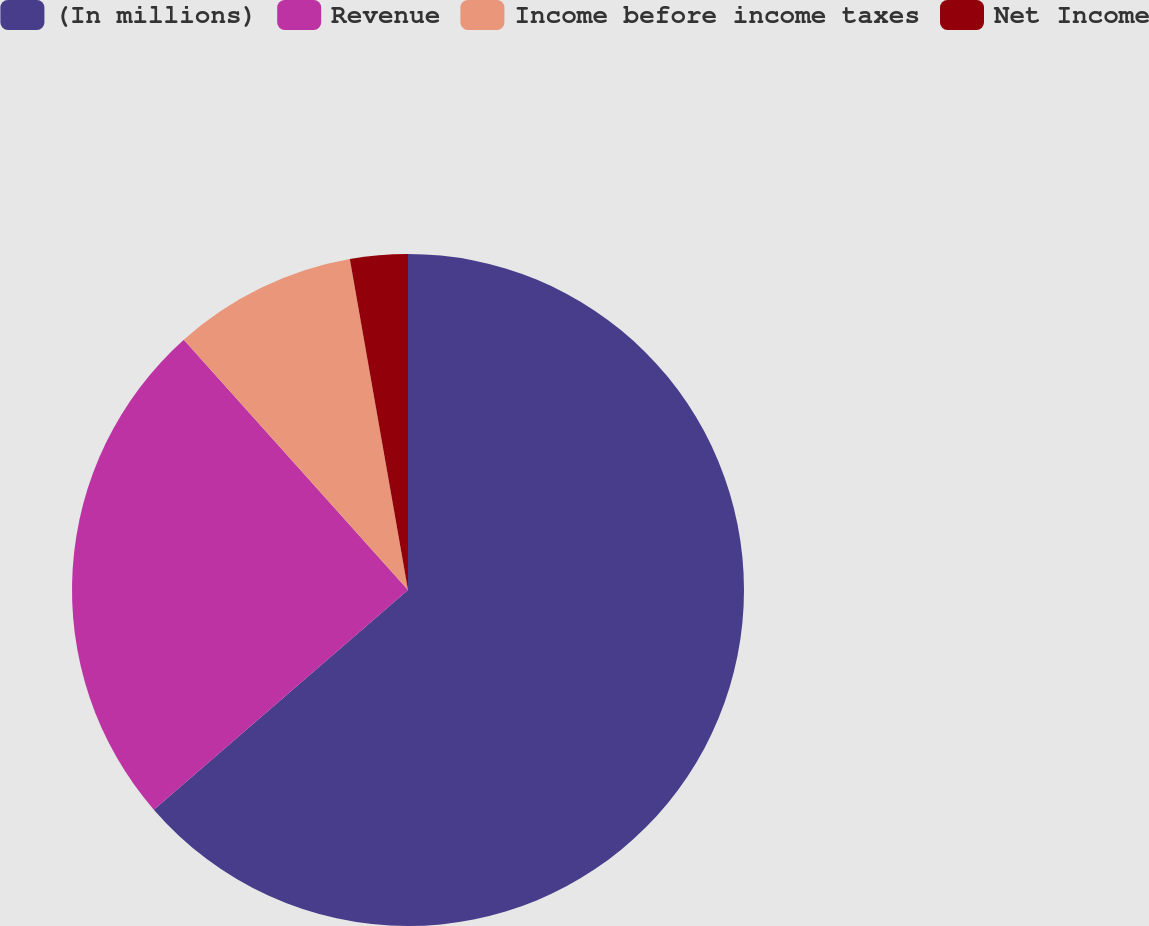<chart> <loc_0><loc_0><loc_500><loc_500><pie_chart><fcel>(In millions)<fcel>Revenue<fcel>Income before income taxes<fcel>Net Income<nl><fcel>63.66%<fcel>24.72%<fcel>8.86%<fcel>2.77%<nl></chart> 